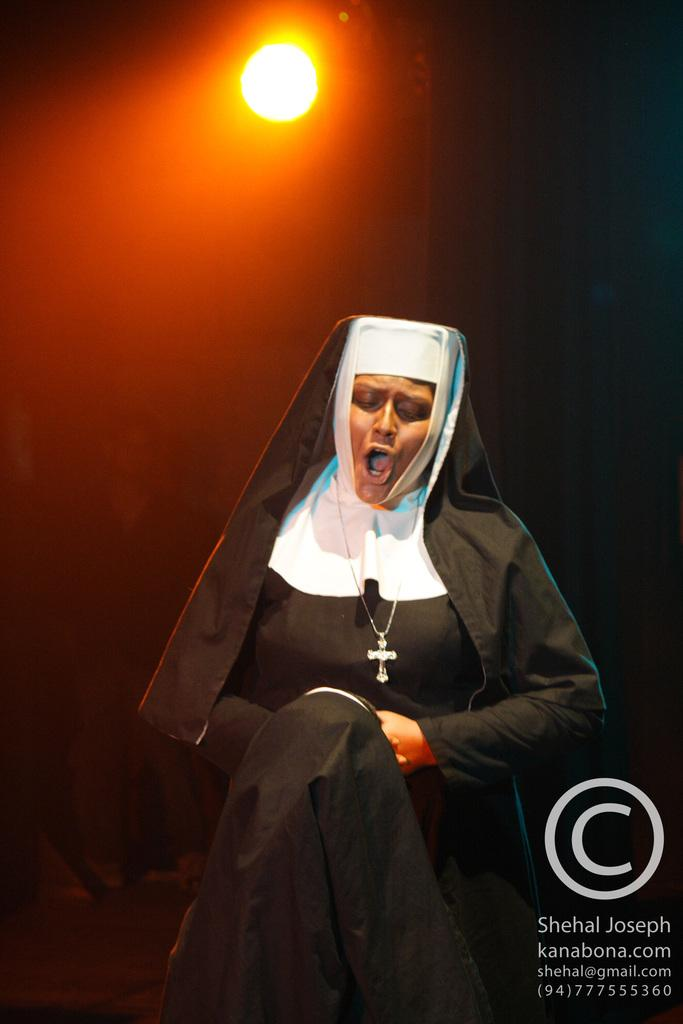Who is the main subject in the image? There is a nun in the image. What is the nun doing in the image? The nun is singing a song. Can you describe any other elements in the image? There is a light visible in the image. How many cats are playing with the wire in the image? There are no cats or wire present in the image. What season is it in the image? The provided facts do not mention the season, so it cannot be determined from the image. 